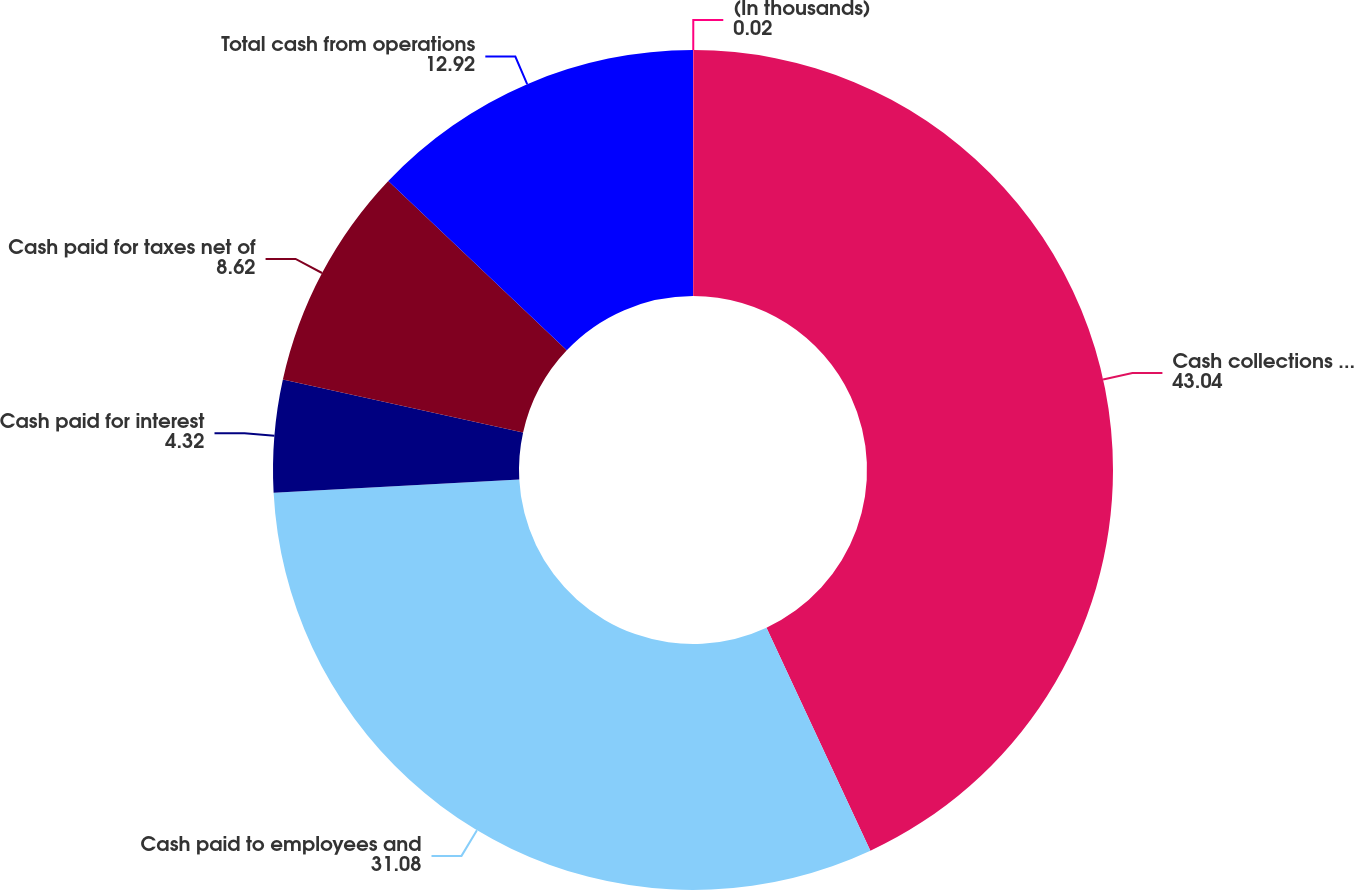<chart> <loc_0><loc_0><loc_500><loc_500><pie_chart><fcel>(In thousands)<fcel>Cash collections from clients<fcel>Cash paid to employees and<fcel>Cash paid for interest<fcel>Cash paid for taxes net of<fcel>Total cash from operations<nl><fcel>0.02%<fcel>43.04%<fcel>31.08%<fcel>4.32%<fcel>8.62%<fcel>12.92%<nl></chart> 